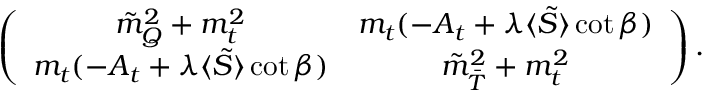Convert formula to latex. <formula><loc_0><loc_0><loc_500><loc_500>\left ( \begin{array} { c c } { { \tilde { m } _ { Q } ^ { 2 } + m _ { t } ^ { 2 } } } & { { m _ { t } ( - A _ { t } + \lambda \langle \tilde { S } \rangle \cot \beta ) } } \\ { { m _ { t } ( - A _ { t } + \lambda \langle \tilde { S } \rangle \cot \beta ) } } & { { \tilde { m } _ { \bar { T } } ^ { 2 } + m _ { t } ^ { 2 } } } \end{array} \right ) .</formula> 